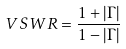<formula> <loc_0><loc_0><loc_500><loc_500>V S W R = \frac { 1 + | \Gamma | } { 1 - | \Gamma | }</formula> 